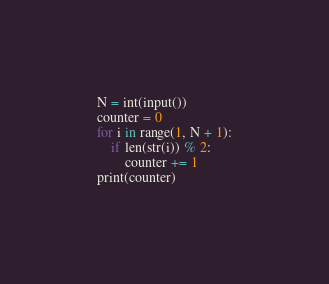Convert code to text. <code><loc_0><loc_0><loc_500><loc_500><_Python_>N = int(input())
counter = 0
for i in range(1, N + 1):
    if len(str(i)) % 2:
        counter += 1
print(counter)
</code> 